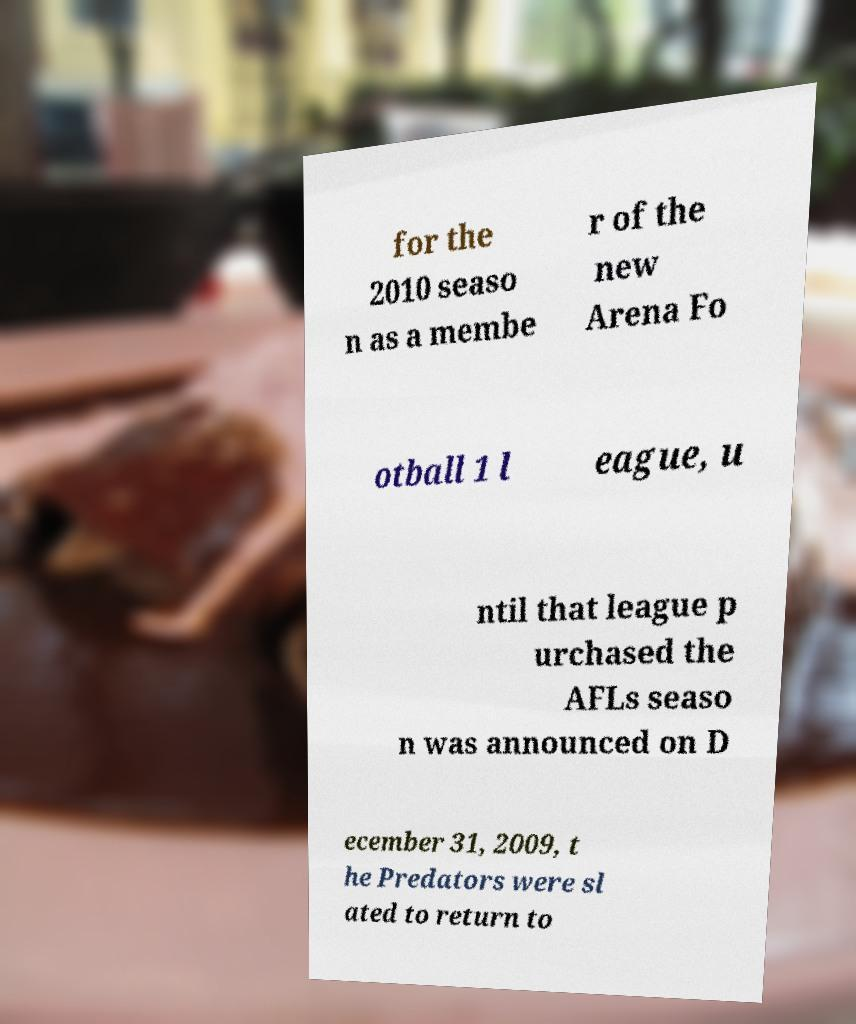I need the written content from this picture converted into text. Can you do that? for the 2010 seaso n as a membe r of the new Arena Fo otball 1 l eague, u ntil that league p urchased the AFLs seaso n was announced on D ecember 31, 2009, t he Predators were sl ated to return to 